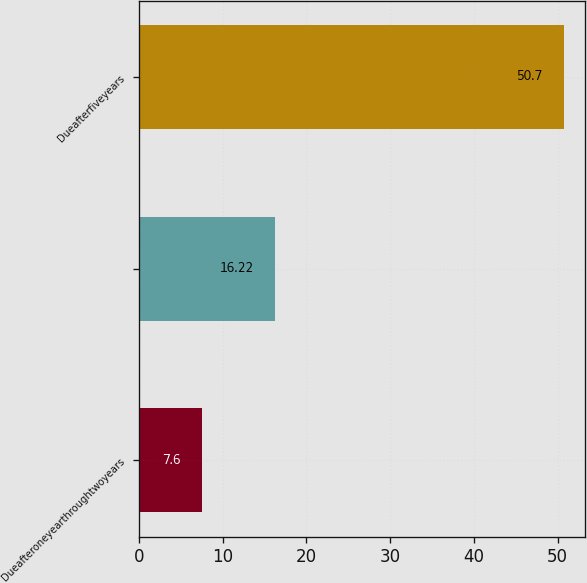<chart> <loc_0><loc_0><loc_500><loc_500><bar_chart><fcel>Dueafteroneyearthroughtwoyears<fcel>Unnamed: 1<fcel>Dueafterfiveyears<nl><fcel>7.6<fcel>16.22<fcel>50.7<nl></chart> 